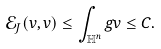Convert formula to latex. <formula><loc_0><loc_0><loc_500><loc_500>\mathcal { E } _ { J } ( v , v ) \leq \int _ { \mathbb { H } ^ { n } } g v \leq C .</formula> 